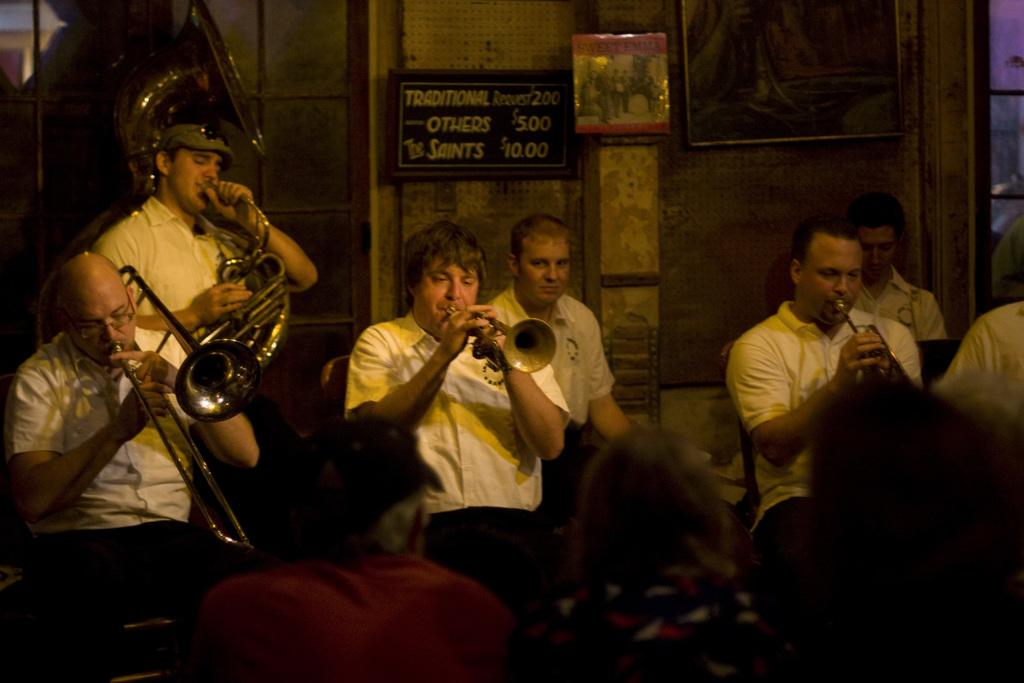What are the people in the image doing? The people in the image are sitting and playing musical instruments. Can you describe the person standing in the image? There is a person standing in the image, but no specific details about their appearance or actions are provided. Who is watching the people playing musical instruments? There is an audience in the image, which suggests that they are watching the people playing musical instruments. What can be seen in the background of the image? In the background, there are boards, a frame on the wall, and a window. What type of grass is growing on the wall in the image? There is no grass present in the image; the wall has a frame on it. What invention is being demonstrated by the people playing musical instruments? The image does not depict any specific invention being demonstrated; it simply shows people playing musical instruments. 